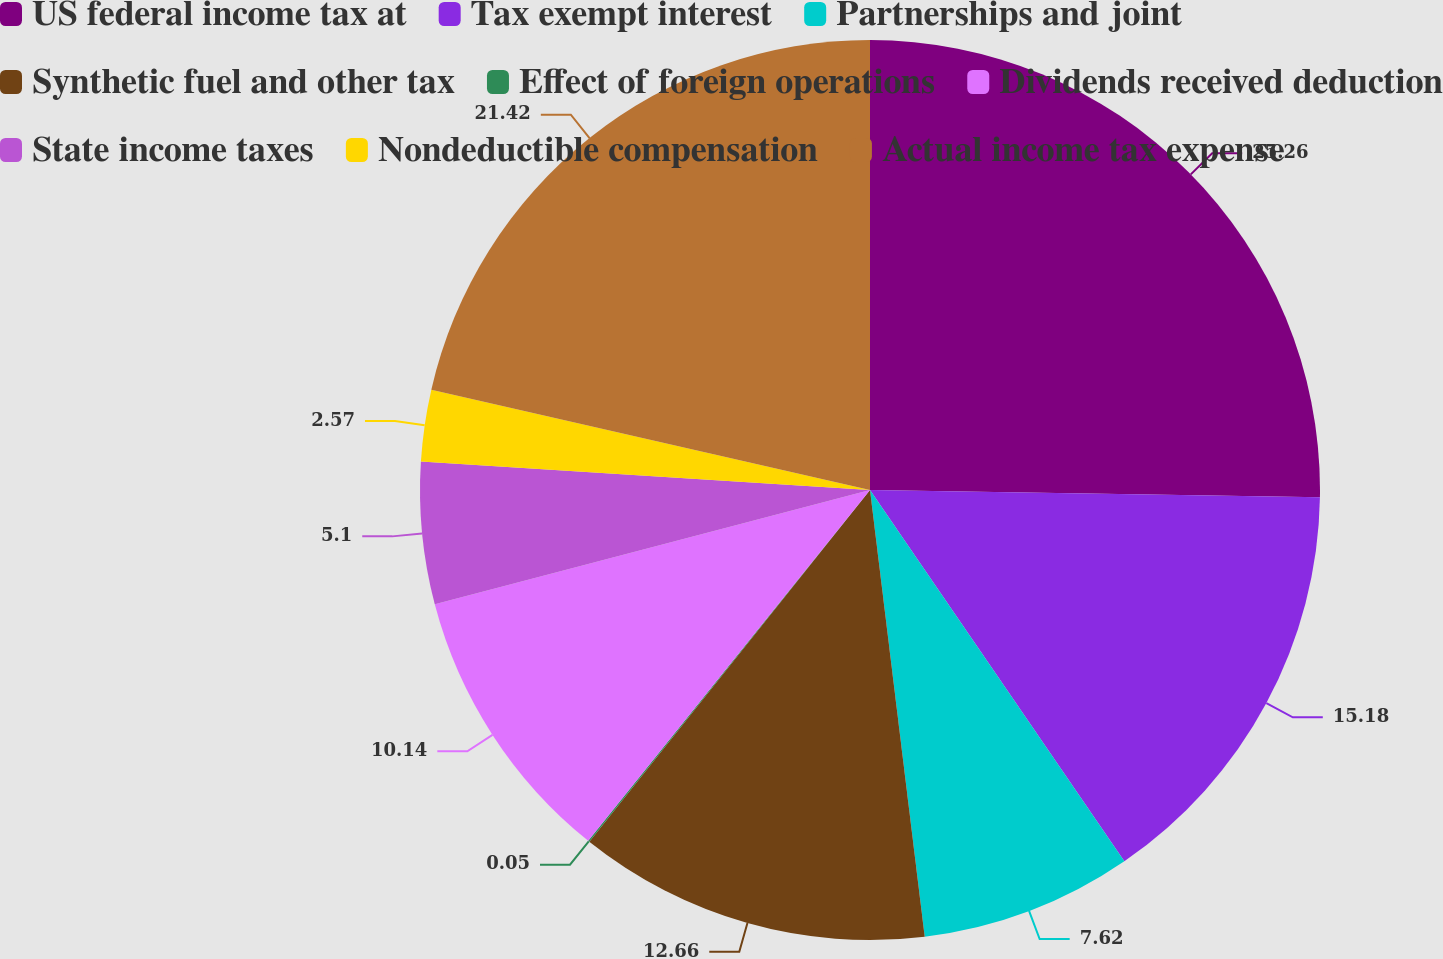<chart> <loc_0><loc_0><loc_500><loc_500><pie_chart><fcel>US federal income tax at<fcel>Tax exempt interest<fcel>Partnerships and joint<fcel>Synthetic fuel and other tax<fcel>Effect of foreign operations<fcel>Dividends received deduction<fcel>State income taxes<fcel>Nondeductible compensation<fcel>Actual income tax expense<nl><fcel>25.26%<fcel>15.18%<fcel>7.62%<fcel>12.66%<fcel>0.05%<fcel>10.14%<fcel>5.1%<fcel>2.57%<fcel>21.42%<nl></chart> 